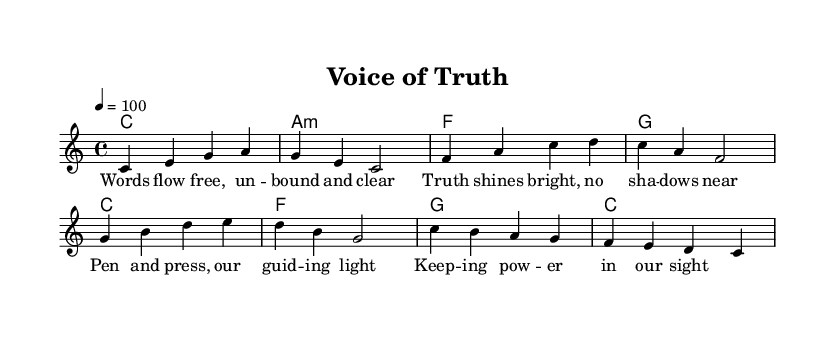What is the key signature of this music? The key signature is C major, which is indicated by the absence of sharps or flats in the key signature section of the sheet music.
Answer: C major What is the time signature of this music? The time signature is 4/4, which is indicated at the beginning of the staff in the sheet music, showing that there are four beats per measure.
Answer: 4/4 What is the tempo marking for this piece? The tempo marking is 4 equals 100, which is stated at the beginning of the sheet music and indicates the speed at which the piece should be played.
Answer: 100 How many measures are in the melody section? There are eight measures in the melody section, as indicated by the layout of the notes and the bars separating them on the staff.
Answer: 8 What is the first note of the melody? The first note of the melody is C, which can be seen at the beginning of the melody line on the staff.
Answer: C What chords are used in the harmonies section? The chords presented are C, A minor, F, and G, as shown in the chord mode section of the sheet music, which denotes the harmonic support for the melody.
Answer: C, A minor, F, G What theme does the song represent based on the lyrics? The song represents the theme of freedom of the press, as indicated by the lyrics celebrating truth, guidance, and the power of written words, connecting to the broader context of using music for social commentary.
Answer: Freedom of the press 